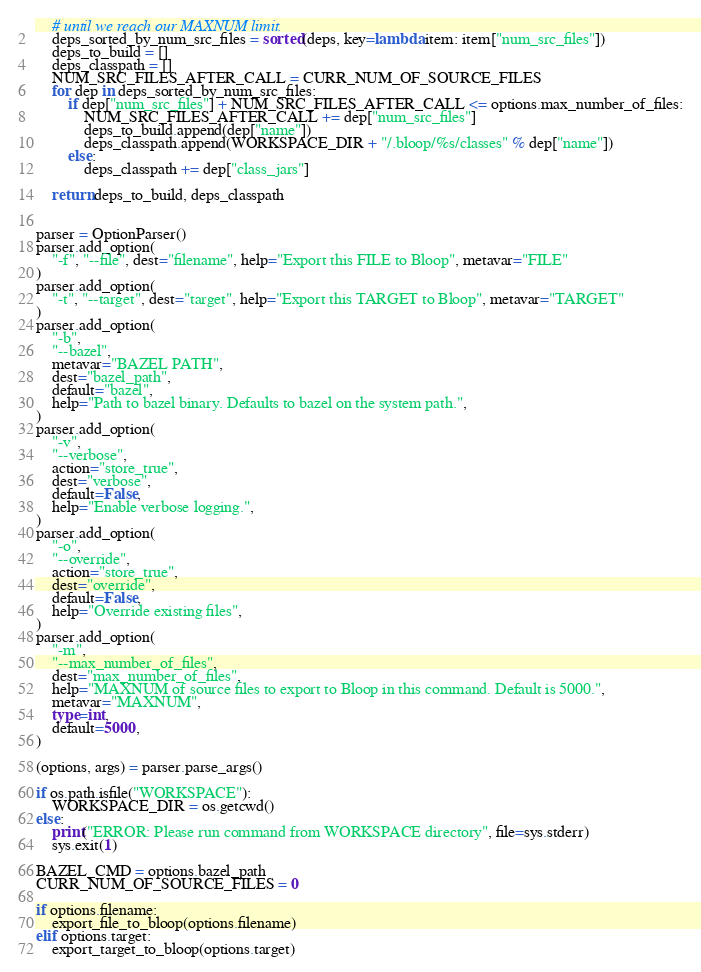Convert code to text. <code><loc_0><loc_0><loc_500><loc_500><_Python_>    # until we reach our MAXNUM limit.
    deps_sorted_by_num_src_files = sorted(deps, key=lambda item: item["num_src_files"])
    deps_to_build = []
    deps_classpath = []
    NUM_SRC_FILES_AFTER_CALL = CURR_NUM_OF_SOURCE_FILES
    for dep in deps_sorted_by_num_src_files:
        if dep["num_src_files"] + NUM_SRC_FILES_AFTER_CALL <= options.max_number_of_files:
            NUM_SRC_FILES_AFTER_CALL += dep["num_src_files"]
            deps_to_build.append(dep["name"])
            deps_classpath.append(WORKSPACE_DIR + "/.bloop/%s/classes" % dep["name"])
        else:
            deps_classpath += dep["class_jars"]

    return deps_to_build, deps_classpath


parser = OptionParser()
parser.add_option(
    "-f", "--file", dest="filename", help="Export this FILE to Bloop", metavar="FILE"
)
parser.add_option(
    "-t", "--target", dest="target", help="Export this TARGET to Bloop", metavar="TARGET"
)
parser.add_option(
    "-b",
    "--bazel",
    metavar="BAZEL PATH",
    dest="bazel_path",
    default="bazel",
    help="Path to bazel binary. Defaults to bazel on the system path.",
)
parser.add_option(
    "-v",
    "--verbose",
    action="store_true",
    dest="verbose",
    default=False,
    help="Enable verbose logging.",
)
parser.add_option(
    "-o",
    "--override",
    action="store_true",
    dest="override",
    default=False,
    help="Override existing files",
)
parser.add_option(
    "-m",
    "--max_number_of_files",
    dest="max_number_of_files",
    help="MAXNUM of source files to export to Bloop in this command. Default is 5000.",
    metavar="MAXNUM",
    type=int,
    default=5000,
)

(options, args) = parser.parse_args()

if os.path.isfile("WORKSPACE"):
    WORKSPACE_DIR = os.getcwd()
else:
    print("ERROR: Please run command from WORKSPACE directory", file=sys.stderr)
    sys.exit(1)

BAZEL_CMD = options.bazel_path
CURR_NUM_OF_SOURCE_FILES = 0

if options.filename:
    export_file_to_bloop(options.filename)
elif options.target:
    export_target_to_bloop(options.target)
</code> 